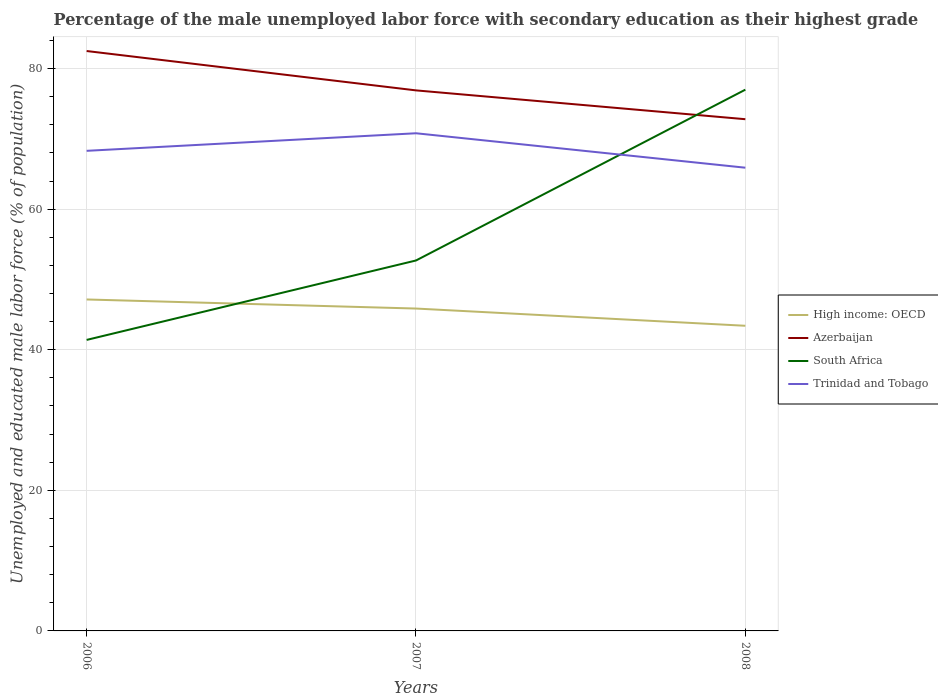Across all years, what is the maximum percentage of the unemployed male labor force with secondary education in High income: OECD?
Make the answer very short. 43.41. What is the total percentage of the unemployed male labor force with secondary education in Trinidad and Tobago in the graph?
Give a very brief answer. 2.4. What is the difference between the highest and the second highest percentage of the unemployed male labor force with secondary education in Trinidad and Tobago?
Give a very brief answer. 4.9. What is the difference between the highest and the lowest percentage of the unemployed male labor force with secondary education in Azerbaijan?
Provide a succinct answer. 1. Is the percentage of the unemployed male labor force with secondary education in Azerbaijan strictly greater than the percentage of the unemployed male labor force with secondary education in High income: OECD over the years?
Provide a succinct answer. No. Does the graph contain any zero values?
Your answer should be compact. No. Where does the legend appear in the graph?
Offer a terse response. Center right. How many legend labels are there?
Your response must be concise. 4. How are the legend labels stacked?
Offer a terse response. Vertical. What is the title of the graph?
Make the answer very short. Percentage of the male unemployed labor force with secondary education as their highest grade. Does "Cambodia" appear as one of the legend labels in the graph?
Provide a succinct answer. No. What is the label or title of the Y-axis?
Your response must be concise. Unemployed and educated male labor force (% of population). What is the Unemployed and educated male labor force (% of population) in High income: OECD in 2006?
Give a very brief answer. 47.16. What is the Unemployed and educated male labor force (% of population) of Azerbaijan in 2006?
Give a very brief answer. 82.5. What is the Unemployed and educated male labor force (% of population) of South Africa in 2006?
Your answer should be very brief. 41.4. What is the Unemployed and educated male labor force (% of population) of Trinidad and Tobago in 2006?
Your answer should be compact. 68.3. What is the Unemployed and educated male labor force (% of population) of High income: OECD in 2007?
Offer a terse response. 45.86. What is the Unemployed and educated male labor force (% of population) of Azerbaijan in 2007?
Provide a succinct answer. 76.9. What is the Unemployed and educated male labor force (% of population) of South Africa in 2007?
Your answer should be compact. 52.7. What is the Unemployed and educated male labor force (% of population) of Trinidad and Tobago in 2007?
Make the answer very short. 70.8. What is the Unemployed and educated male labor force (% of population) in High income: OECD in 2008?
Provide a succinct answer. 43.41. What is the Unemployed and educated male labor force (% of population) of Azerbaijan in 2008?
Your response must be concise. 72.8. What is the Unemployed and educated male labor force (% of population) of South Africa in 2008?
Ensure brevity in your answer.  77. What is the Unemployed and educated male labor force (% of population) in Trinidad and Tobago in 2008?
Provide a short and direct response. 65.9. Across all years, what is the maximum Unemployed and educated male labor force (% of population) of High income: OECD?
Ensure brevity in your answer.  47.16. Across all years, what is the maximum Unemployed and educated male labor force (% of population) of Azerbaijan?
Give a very brief answer. 82.5. Across all years, what is the maximum Unemployed and educated male labor force (% of population) in Trinidad and Tobago?
Your answer should be very brief. 70.8. Across all years, what is the minimum Unemployed and educated male labor force (% of population) of High income: OECD?
Offer a very short reply. 43.41. Across all years, what is the minimum Unemployed and educated male labor force (% of population) of Azerbaijan?
Your response must be concise. 72.8. Across all years, what is the minimum Unemployed and educated male labor force (% of population) of South Africa?
Give a very brief answer. 41.4. Across all years, what is the minimum Unemployed and educated male labor force (% of population) of Trinidad and Tobago?
Offer a terse response. 65.9. What is the total Unemployed and educated male labor force (% of population) in High income: OECD in the graph?
Ensure brevity in your answer.  136.43. What is the total Unemployed and educated male labor force (% of population) in Azerbaijan in the graph?
Keep it short and to the point. 232.2. What is the total Unemployed and educated male labor force (% of population) of South Africa in the graph?
Your answer should be compact. 171.1. What is the total Unemployed and educated male labor force (% of population) in Trinidad and Tobago in the graph?
Provide a short and direct response. 205. What is the difference between the Unemployed and educated male labor force (% of population) in High income: OECD in 2006 and that in 2007?
Keep it short and to the point. 1.29. What is the difference between the Unemployed and educated male labor force (% of population) in High income: OECD in 2006 and that in 2008?
Provide a short and direct response. 3.74. What is the difference between the Unemployed and educated male labor force (% of population) in South Africa in 2006 and that in 2008?
Your answer should be compact. -35.6. What is the difference between the Unemployed and educated male labor force (% of population) in High income: OECD in 2007 and that in 2008?
Ensure brevity in your answer.  2.45. What is the difference between the Unemployed and educated male labor force (% of population) in South Africa in 2007 and that in 2008?
Make the answer very short. -24.3. What is the difference between the Unemployed and educated male labor force (% of population) in High income: OECD in 2006 and the Unemployed and educated male labor force (% of population) in Azerbaijan in 2007?
Make the answer very short. -29.75. What is the difference between the Unemployed and educated male labor force (% of population) in High income: OECD in 2006 and the Unemployed and educated male labor force (% of population) in South Africa in 2007?
Ensure brevity in your answer.  -5.54. What is the difference between the Unemployed and educated male labor force (% of population) of High income: OECD in 2006 and the Unemployed and educated male labor force (% of population) of Trinidad and Tobago in 2007?
Make the answer very short. -23.64. What is the difference between the Unemployed and educated male labor force (% of population) of Azerbaijan in 2006 and the Unemployed and educated male labor force (% of population) of South Africa in 2007?
Give a very brief answer. 29.8. What is the difference between the Unemployed and educated male labor force (% of population) of South Africa in 2006 and the Unemployed and educated male labor force (% of population) of Trinidad and Tobago in 2007?
Provide a short and direct response. -29.4. What is the difference between the Unemployed and educated male labor force (% of population) in High income: OECD in 2006 and the Unemployed and educated male labor force (% of population) in Azerbaijan in 2008?
Provide a succinct answer. -25.64. What is the difference between the Unemployed and educated male labor force (% of population) of High income: OECD in 2006 and the Unemployed and educated male labor force (% of population) of South Africa in 2008?
Offer a very short reply. -29.84. What is the difference between the Unemployed and educated male labor force (% of population) of High income: OECD in 2006 and the Unemployed and educated male labor force (% of population) of Trinidad and Tobago in 2008?
Your answer should be very brief. -18.75. What is the difference between the Unemployed and educated male labor force (% of population) of Azerbaijan in 2006 and the Unemployed and educated male labor force (% of population) of South Africa in 2008?
Your answer should be very brief. 5.5. What is the difference between the Unemployed and educated male labor force (% of population) of Azerbaijan in 2006 and the Unemployed and educated male labor force (% of population) of Trinidad and Tobago in 2008?
Offer a very short reply. 16.6. What is the difference between the Unemployed and educated male labor force (% of population) of South Africa in 2006 and the Unemployed and educated male labor force (% of population) of Trinidad and Tobago in 2008?
Offer a terse response. -24.5. What is the difference between the Unemployed and educated male labor force (% of population) in High income: OECD in 2007 and the Unemployed and educated male labor force (% of population) in Azerbaijan in 2008?
Offer a very short reply. -26.94. What is the difference between the Unemployed and educated male labor force (% of population) of High income: OECD in 2007 and the Unemployed and educated male labor force (% of population) of South Africa in 2008?
Your response must be concise. -31.14. What is the difference between the Unemployed and educated male labor force (% of population) in High income: OECD in 2007 and the Unemployed and educated male labor force (% of population) in Trinidad and Tobago in 2008?
Ensure brevity in your answer.  -20.04. What is the difference between the Unemployed and educated male labor force (% of population) of Azerbaijan in 2007 and the Unemployed and educated male labor force (% of population) of South Africa in 2008?
Offer a very short reply. -0.1. What is the difference between the Unemployed and educated male labor force (% of population) of Azerbaijan in 2007 and the Unemployed and educated male labor force (% of population) of Trinidad and Tobago in 2008?
Provide a succinct answer. 11. What is the average Unemployed and educated male labor force (% of population) in High income: OECD per year?
Your response must be concise. 45.48. What is the average Unemployed and educated male labor force (% of population) in Azerbaijan per year?
Provide a succinct answer. 77.4. What is the average Unemployed and educated male labor force (% of population) of South Africa per year?
Give a very brief answer. 57.03. What is the average Unemployed and educated male labor force (% of population) of Trinidad and Tobago per year?
Provide a succinct answer. 68.33. In the year 2006, what is the difference between the Unemployed and educated male labor force (% of population) in High income: OECD and Unemployed and educated male labor force (% of population) in Azerbaijan?
Provide a short and direct response. -35.34. In the year 2006, what is the difference between the Unemployed and educated male labor force (% of population) of High income: OECD and Unemployed and educated male labor force (% of population) of South Africa?
Your answer should be compact. 5.75. In the year 2006, what is the difference between the Unemployed and educated male labor force (% of population) of High income: OECD and Unemployed and educated male labor force (% of population) of Trinidad and Tobago?
Give a very brief answer. -21.14. In the year 2006, what is the difference between the Unemployed and educated male labor force (% of population) of Azerbaijan and Unemployed and educated male labor force (% of population) of South Africa?
Your answer should be very brief. 41.1. In the year 2006, what is the difference between the Unemployed and educated male labor force (% of population) in South Africa and Unemployed and educated male labor force (% of population) in Trinidad and Tobago?
Make the answer very short. -26.9. In the year 2007, what is the difference between the Unemployed and educated male labor force (% of population) of High income: OECD and Unemployed and educated male labor force (% of population) of Azerbaijan?
Keep it short and to the point. -31.04. In the year 2007, what is the difference between the Unemployed and educated male labor force (% of population) of High income: OECD and Unemployed and educated male labor force (% of population) of South Africa?
Offer a very short reply. -6.84. In the year 2007, what is the difference between the Unemployed and educated male labor force (% of population) of High income: OECD and Unemployed and educated male labor force (% of population) of Trinidad and Tobago?
Your answer should be very brief. -24.94. In the year 2007, what is the difference between the Unemployed and educated male labor force (% of population) in Azerbaijan and Unemployed and educated male labor force (% of population) in South Africa?
Your answer should be very brief. 24.2. In the year 2007, what is the difference between the Unemployed and educated male labor force (% of population) of South Africa and Unemployed and educated male labor force (% of population) of Trinidad and Tobago?
Your answer should be compact. -18.1. In the year 2008, what is the difference between the Unemployed and educated male labor force (% of population) of High income: OECD and Unemployed and educated male labor force (% of population) of Azerbaijan?
Provide a succinct answer. -29.39. In the year 2008, what is the difference between the Unemployed and educated male labor force (% of population) of High income: OECD and Unemployed and educated male labor force (% of population) of South Africa?
Offer a terse response. -33.59. In the year 2008, what is the difference between the Unemployed and educated male labor force (% of population) of High income: OECD and Unemployed and educated male labor force (% of population) of Trinidad and Tobago?
Provide a succinct answer. -22.49. In the year 2008, what is the difference between the Unemployed and educated male labor force (% of population) of Azerbaijan and Unemployed and educated male labor force (% of population) of Trinidad and Tobago?
Your answer should be compact. 6.9. In the year 2008, what is the difference between the Unemployed and educated male labor force (% of population) of South Africa and Unemployed and educated male labor force (% of population) of Trinidad and Tobago?
Ensure brevity in your answer.  11.1. What is the ratio of the Unemployed and educated male labor force (% of population) of High income: OECD in 2006 to that in 2007?
Your answer should be compact. 1.03. What is the ratio of the Unemployed and educated male labor force (% of population) in Azerbaijan in 2006 to that in 2007?
Give a very brief answer. 1.07. What is the ratio of the Unemployed and educated male labor force (% of population) in South Africa in 2006 to that in 2007?
Offer a very short reply. 0.79. What is the ratio of the Unemployed and educated male labor force (% of population) of Trinidad and Tobago in 2006 to that in 2007?
Provide a short and direct response. 0.96. What is the ratio of the Unemployed and educated male labor force (% of population) of High income: OECD in 2006 to that in 2008?
Make the answer very short. 1.09. What is the ratio of the Unemployed and educated male labor force (% of population) in Azerbaijan in 2006 to that in 2008?
Provide a succinct answer. 1.13. What is the ratio of the Unemployed and educated male labor force (% of population) in South Africa in 2006 to that in 2008?
Make the answer very short. 0.54. What is the ratio of the Unemployed and educated male labor force (% of population) of Trinidad and Tobago in 2006 to that in 2008?
Provide a short and direct response. 1.04. What is the ratio of the Unemployed and educated male labor force (% of population) of High income: OECD in 2007 to that in 2008?
Ensure brevity in your answer.  1.06. What is the ratio of the Unemployed and educated male labor force (% of population) of Azerbaijan in 2007 to that in 2008?
Your answer should be very brief. 1.06. What is the ratio of the Unemployed and educated male labor force (% of population) in South Africa in 2007 to that in 2008?
Give a very brief answer. 0.68. What is the ratio of the Unemployed and educated male labor force (% of population) in Trinidad and Tobago in 2007 to that in 2008?
Your response must be concise. 1.07. What is the difference between the highest and the second highest Unemployed and educated male labor force (% of population) of High income: OECD?
Give a very brief answer. 1.29. What is the difference between the highest and the second highest Unemployed and educated male labor force (% of population) of South Africa?
Offer a terse response. 24.3. What is the difference between the highest and the lowest Unemployed and educated male labor force (% of population) in High income: OECD?
Provide a short and direct response. 3.74. What is the difference between the highest and the lowest Unemployed and educated male labor force (% of population) of South Africa?
Your response must be concise. 35.6. 